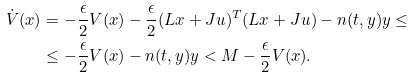<formula> <loc_0><loc_0><loc_500><loc_500>\dot { V } ( x ) & = - \frac { \epsilon } { 2 } V ( x ) - \frac { \epsilon } { 2 } ( L x + J u ) ^ { T } ( L x + J u ) - n ( t , y ) y \leq \\ & \leq - \frac { \epsilon } { 2 } V ( x ) - n ( t , y ) y < M - \frac { \epsilon } { 2 } V ( x ) .</formula> 